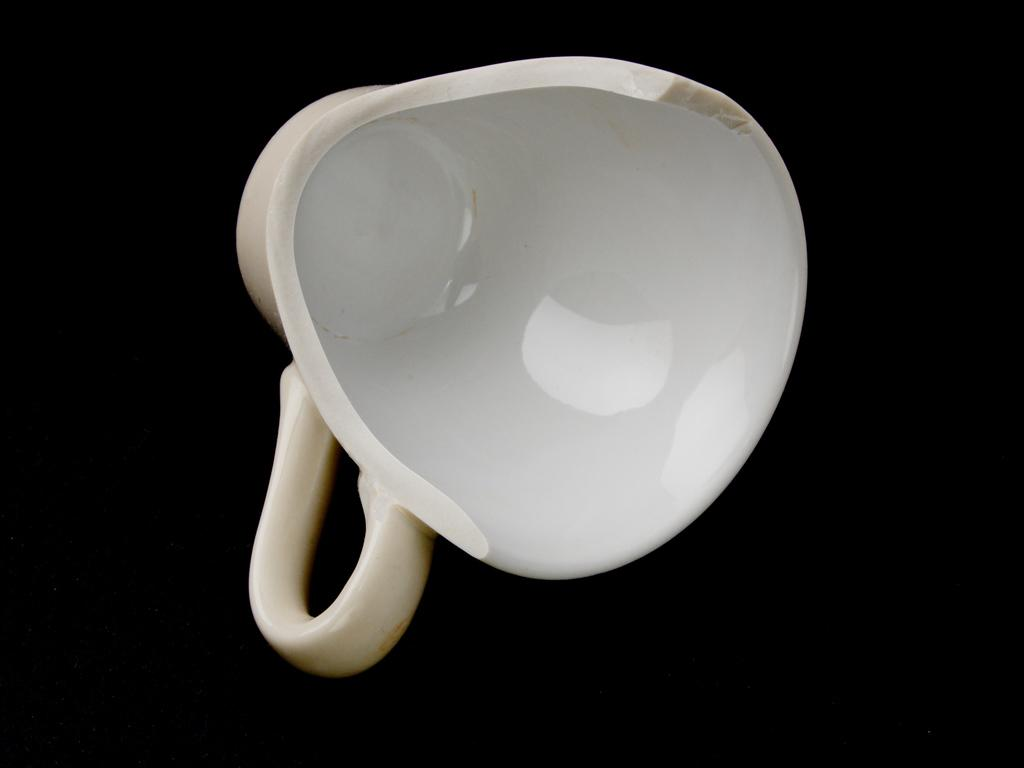What object is broken in the image? There is a broken cup in the image. Where is the broken cup located? The broken cup is placed on a surface. What is the purpose of the carriage in the image? There is no carriage present in the image; it only features a broken cup placed on a surface. 